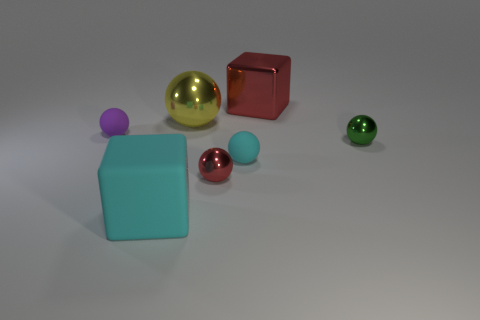There is a purple rubber ball behind the tiny green metallic thing; is its size the same as the cyan matte object that is behind the rubber block?
Make the answer very short. Yes. Is the number of large metallic balls that are in front of the small red sphere greater than the number of rubber blocks that are on the left side of the metallic block?
Make the answer very short. No. What number of other purple metallic objects are the same shape as the small purple object?
Your answer should be very brief. 0. What material is the green sphere that is the same size as the purple rubber thing?
Keep it short and to the point. Metal. Is there a ball made of the same material as the tiny cyan thing?
Your answer should be compact. Yes. Are there fewer tiny cyan rubber objects that are behind the green metal thing than big cyan things?
Your answer should be compact. Yes. What material is the small cyan object on the right side of the large cube in front of the tiny green ball made of?
Ensure brevity in your answer.  Rubber. There is a thing that is behind the purple matte ball and to the right of the small cyan thing; what shape is it?
Ensure brevity in your answer.  Cube. What number of other objects are the same color as the large metal cube?
Ensure brevity in your answer.  1. How many objects are metallic objects that are behind the small red object or tiny red metallic objects?
Give a very brief answer. 4. 